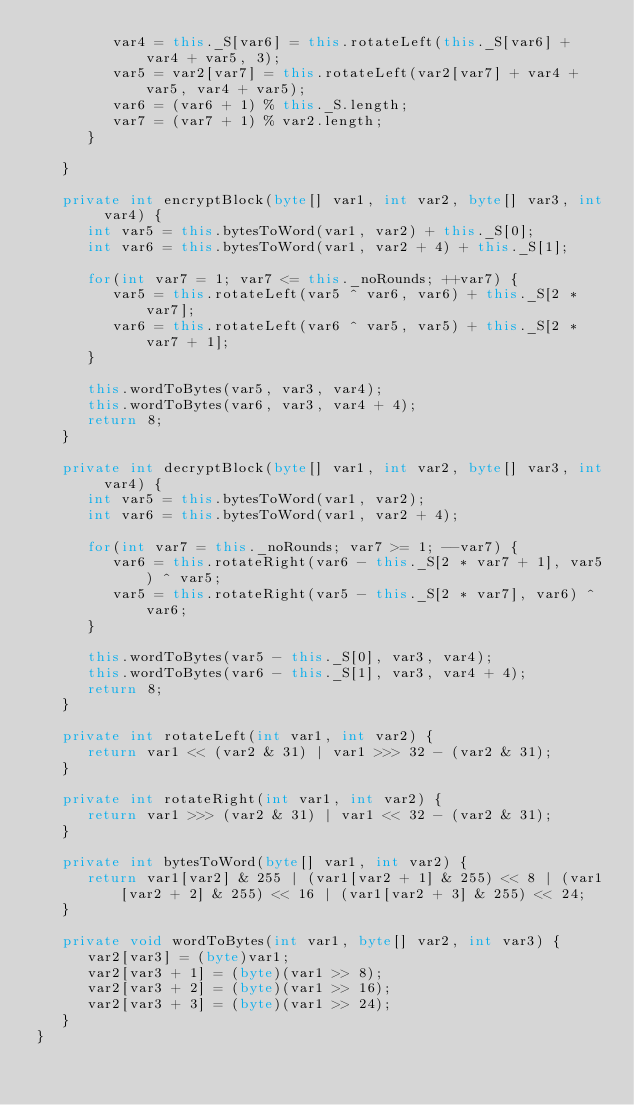Convert code to text. <code><loc_0><loc_0><loc_500><loc_500><_Java_>         var4 = this._S[var6] = this.rotateLeft(this._S[var6] + var4 + var5, 3);
         var5 = var2[var7] = this.rotateLeft(var2[var7] + var4 + var5, var4 + var5);
         var6 = (var6 + 1) % this._S.length;
         var7 = (var7 + 1) % var2.length;
      }

   }

   private int encryptBlock(byte[] var1, int var2, byte[] var3, int var4) {
      int var5 = this.bytesToWord(var1, var2) + this._S[0];
      int var6 = this.bytesToWord(var1, var2 + 4) + this._S[1];

      for(int var7 = 1; var7 <= this._noRounds; ++var7) {
         var5 = this.rotateLeft(var5 ^ var6, var6) + this._S[2 * var7];
         var6 = this.rotateLeft(var6 ^ var5, var5) + this._S[2 * var7 + 1];
      }

      this.wordToBytes(var5, var3, var4);
      this.wordToBytes(var6, var3, var4 + 4);
      return 8;
   }

   private int decryptBlock(byte[] var1, int var2, byte[] var3, int var4) {
      int var5 = this.bytesToWord(var1, var2);
      int var6 = this.bytesToWord(var1, var2 + 4);

      for(int var7 = this._noRounds; var7 >= 1; --var7) {
         var6 = this.rotateRight(var6 - this._S[2 * var7 + 1], var5) ^ var5;
         var5 = this.rotateRight(var5 - this._S[2 * var7], var6) ^ var6;
      }

      this.wordToBytes(var5 - this._S[0], var3, var4);
      this.wordToBytes(var6 - this._S[1], var3, var4 + 4);
      return 8;
   }

   private int rotateLeft(int var1, int var2) {
      return var1 << (var2 & 31) | var1 >>> 32 - (var2 & 31);
   }

   private int rotateRight(int var1, int var2) {
      return var1 >>> (var2 & 31) | var1 << 32 - (var2 & 31);
   }

   private int bytesToWord(byte[] var1, int var2) {
      return var1[var2] & 255 | (var1[var2 + 1] & 255) << 8 | (var1[var2 + 2] & 255) << 16 | (var1[var2 + 3] & 255) << 24;
   }

   private void wordToBytes(int var1, byte[] var2, int var3) {
      var2[var3] = (byte)var1;
      var2[var3 + 1] = (byte)(var1 >> 8);
      var2[var3 + 2] = (byte)(var1 >> 16);
      var2[var3 + 3] = (byte)(var1 >> 24);
   }
}
</code> 